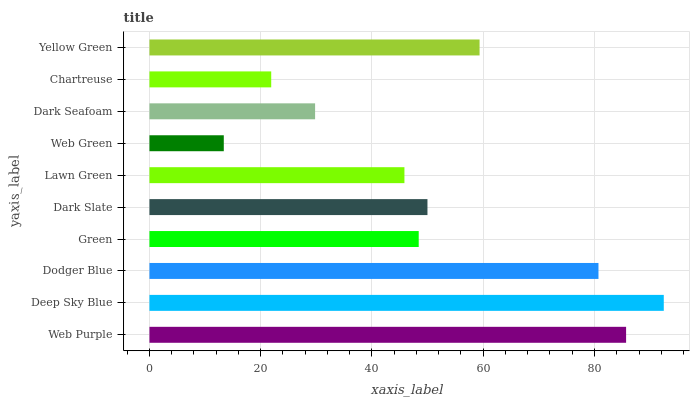Is Web Green the minimum?
Answer yes or no. Yes. Is Deep Sky Blue the maximum?
Answer yes or no. Yes. Is Dodger Blue the minimum?
Answer yes or no. No. Is Dodger Blue the maximum?
Answer yes or no. No. Is Deep Sky Blue greater than Dodger Blue?
Answer yes or no. Yes. Is Dodger Blue less than Deep Sky Blue?
Answer yes or no. Yes. Is Dodger Blue greater than Deep Sky Blue?
Answer yes or no. No. Is Deep Sky Blue less than Dodger Blue?
Answer yes or no. No. Is Dark Slate the high median?
Answer yes or no. Yes. Is Green the low median?
Answer yes or no. Yes. Is Chartreuse the high median?
Answer yes or no. No. Is Dodger Blue the low median?
Answer yes or no. No. 